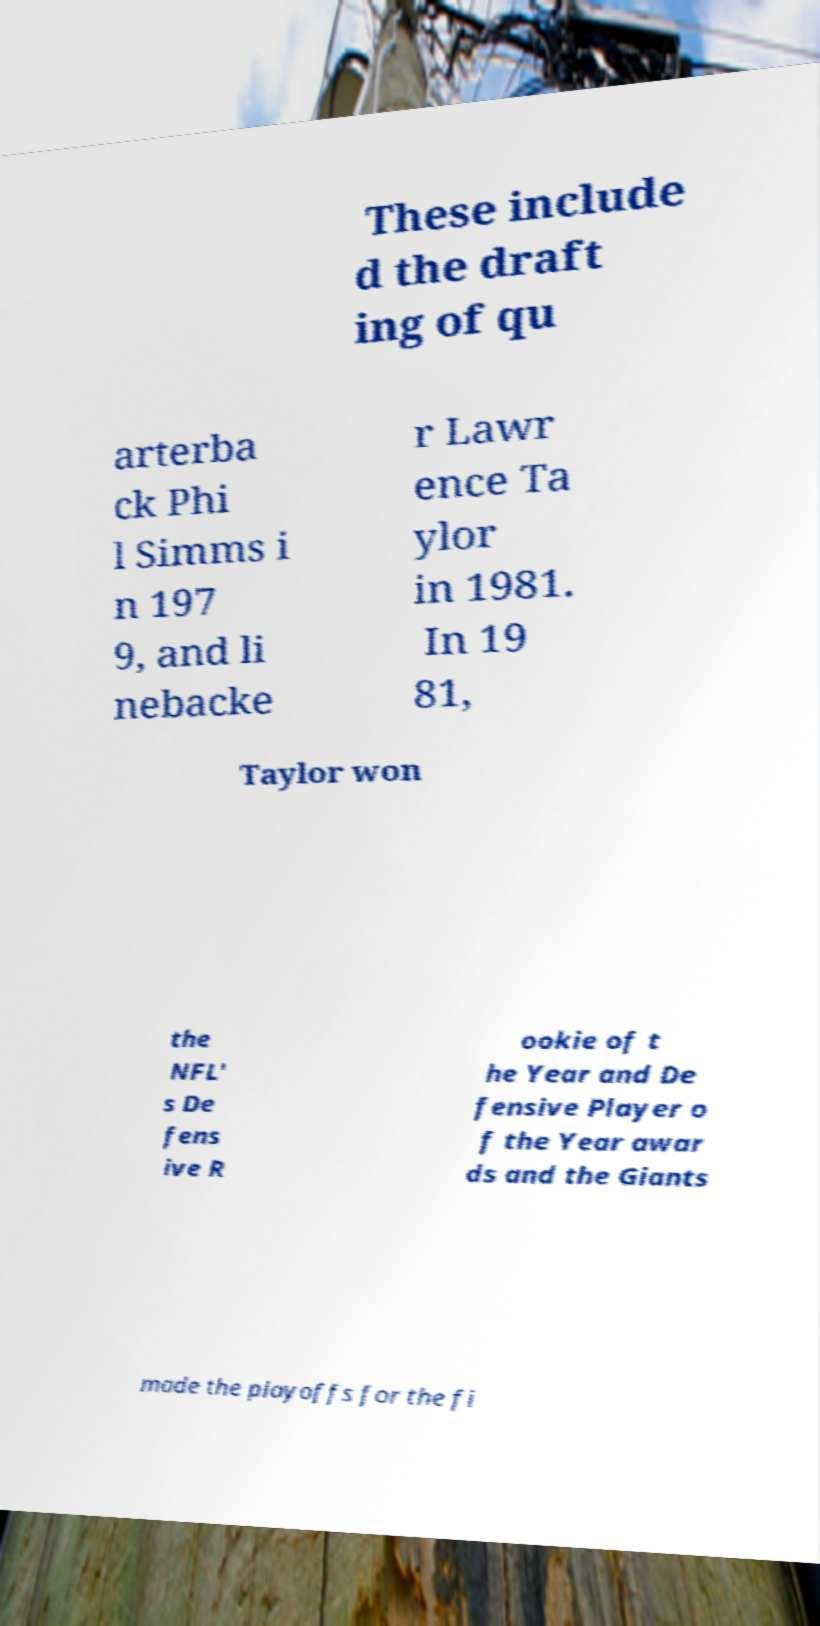For documentation purposes, I need the text within this image transcribed. Could you provide that? These include d the draft ing of qu arterba ck Phi l Simms i n 197 9, and li nebacke r Lawr ence Ta ylor in 1981. In 19 81, Taylor won the NFL' s De fens ive R ookie of t he Year and De fensive Player o f the Year awar ds and the Giants made the playoffs for the fi 